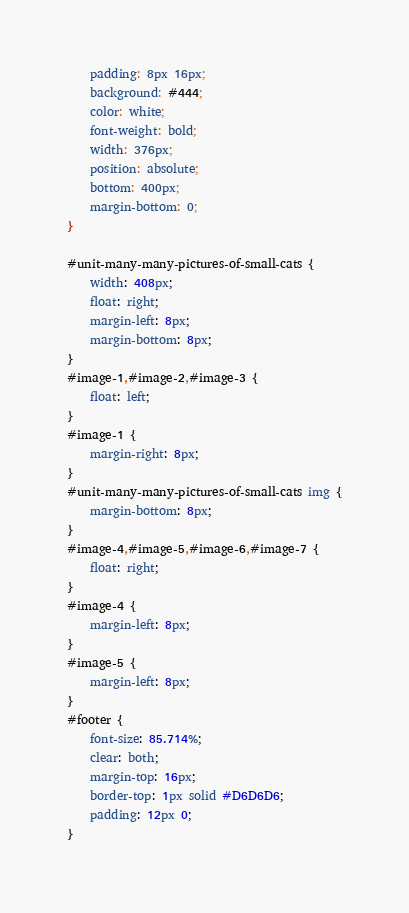<code> <loc_0><loc_0><loc_500><loc_500><_CSS_>	padding: 8px 16px;
	background: #444;
	color: white;
	font-weight: bold;
	width: 376px;
	position: absolute;
	bottom: 400px;
	margin-bottom: 0;
}

#unit-many-many-pictures-of-small-cats {
	width: 408px;
	float: right;
	margin-left: 8px;
	margin-bottom: 8px;
}
#image-1,#image-2,#image-3 {
	float: left;
}
#image-1 {
	margin-right: 8px;
}
#unit-many-many-pictures-of-small-cats img {
	margin-bottom: 8px;
}
#image-4,#image-5,#image-6,#image-7 {
	float: right;
}
#image-4 {
	margin-left: 8px;
}
#image-5 {
	margin-left: 8px;
}
#footer {
	font-size: 85.714%;
	clear: both;
	margin-top: 16px;
	border-top: 1px solid #D6D6D6;
	padding: 12px 0;
}



</code> 